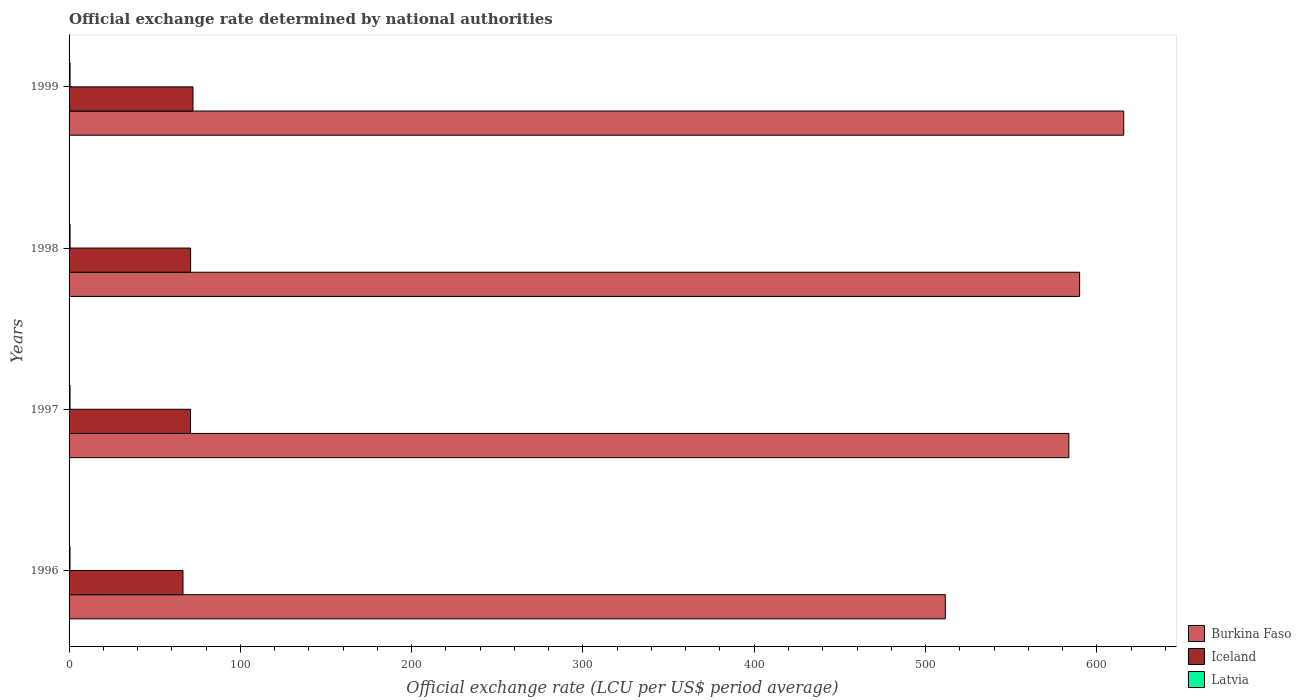How many different coloured bars are there?
Provide a short and direct response. 3. Are the number of bars per tick equal to the number of legend labels?
Keep it short and to the point. Yes. Are the number of bars on each tick of the Y-axis equal?
Make the answer very short. Yes. In how many cases, is the number of bars for a given year not equal to the number of legend labels?
Provide a short and direct response. 0. What is the official exchange rate in Burkina Faso in 1997?
Offer a very short reply. 583.67. Across all years, what is the maximum official exchange rate in Latvia?
Provide a short and direct response. 0.59. Across all years, what is the minimum official exchange rate in Iceland?
Provide a succinct answer. 66.5. What is the total official exchange rate in Latvia in the graph?
Provide a succinct answer. 2.31. What is the difference between the official exchange rate in Burkina Faso in 1997 and that in 1999?
Offer a very short reply. -32.03. What is the difference between the official exchange rate in Latvia in 1998 and the official exchange rate in Iceland in 1999?
Your answer should be compact. -71.75. What is the average official exchange rate in Burkina Faso per year?
Your response must be concise. 575.22. In the year 1998, what is the difference between the official exchange rate in Latvia and official exchange rate in Burkina Faso?
Offer a very short reply. -589.36. What is the ratio of the official exchange rate in Burkina Faso in 1997 to that in 1999?
Your answer should be very brief. 0.95. What is the difference between the highest and the second highest official exchange rate in Burkina Faso?
Your answer should be compact. 25.75. What is the difference between the highest and the lowest official exchange rate in Burkina Faso?
Your response must be concise. 104.15. Is the sum of the official exchange rate in Burkina Faso in 1996 and 1998 greater than the maximum official exchange rate in Iceland across all years?
Give a very brief answer. Yes. What does the 1st bar from the top in 1998 represents?
Make the answer very short. Latvia. What does the 1st bar from the bottom in 1998 represents?
Offer a terse response. Burkina Faso. Are the values on the major ticks of X-axis written in scientific E-notation?
Provide a short and direct response. No. Where does the legend appear in the graph?
Your response must be concise. Bottom right. How many legend labels are there?
Your response must be concise. 3. How are the legend labels stacked?
Offer a very short reply. Vertical. What is the title of the graph?
Give a very brief answer. Official exchange rate determined by national authorities. Does "Turkey" appear as one of the legend labels in the graph?
Ensure brevity in your answer.  No. What is the label or title of the X-axis?
Keep it short and to the point. Official exchange rate (LCU per US$ period average). What is the Official exchange rate (LCU per US$ period average) in Burkina Faso in 1996?
Offer a very short reply. 511.55. What is the Official exchange rate (LCU per US$ period average) in Iceland in 1996?
Offer a terse response. 66.5. What is the Official exchange rate (LCU per US$ period average) of Latvia in 1996?
Your answer should be compact. 0.55. What is the Official exchange rate (LCU per US$ period average) in Burkina Faso in 1997?
Your answer should be very brief. 583.67. What is the Official exchange rate (LCU per US$ period average) in Iceland in 1997?
Give a very brief answer. 70.9. What is the Official exchange rate (LCU per US$ period average) of Latvia in 1997?
Your answer should be compact. 0.58. What is the Official exchange rate (LCU per US$ period average) of Burkina Faso in 1998?
Your response must be concise. 589.95. What is the Official exchange rate (LCU per US$ period average) in Iceland in 1998?
Your answer should be compact. 70.96. What is the Official exchange rate (LCU per US$ period average) of Latvia in 1998?
Offer a very short reply. 0.59. What is the Official exchange rate (LCU per US$ period average) in Burkina Faso in 1999?
Offer a terse response. 615.7. What is the Official exchange rate (LCU per US$ period average) in Iceland in 1999?
Give a very brief answer. 72.34. What is the Official exchange rate (LCU per US$ period average) in Latvia in 1999?
Provide a short and direct response. 0.59. Across all years, what is the maximum Official exchange rate (LCU per US$ period average) in Burkina Faso?
Keep it short and to the point. 615.7. Across all years, what is the maximum Official exchange rate (LCU per US$ period average) of Iceland?
Provide a succinct answer. 72.34. Across all years, what is the maximum Official exchange rate (LCU per US$ period average) in Latvia?
Provide a succinct answer. 0.59. Across all years, what is the minimum Official exchange rate (LCU per US$ period average) of Burkina Faso?
Make the answer very short. 511.55. Across all years, what is the minimum Official exchange rate (LCU per US$ period average) of Iceland?
Make the answer very short. 66.5. Across all years, what is the minimum Official exchange rate (LCU per US$ period average) in Latvia?
Make the answer very short. 0.55. What is the total Official exchange rate (LCU per US$ period average) of Burkina Faso in the graph?
Offer a very short reply. 2300.87. What is the total Official exchange rate (LCU per US$ period average) of Iceland in the graph?
Ensure brevity in your answer.  280.7. What is the total Official exchange rate (LCU per US$ period average) in Latvia in the graph?
Provide a succinct answer. 2.31. What is the difference between the Official exchange rate (LCU per US$ period average) of Burkina Faso in 1996 and that in 1997?
Keep it short and to the point. -72.12. What is the difference between the Official exchange rate (LCU per US$ period average) of Iceland in 1996 and that in 1997?
Ensure brevity in your answer.  -4.4. What is the difference between the Official exchange rate (LCU per US$ period average) in Latvia in 1996 and that in 1997?
Give a very brief answer. -0.03. What is the difference between the Official exchange rate (LCU per US$ period average) of Burkina Faso in 1996 and that in 1998?
Give a very brief answer. -78.4. What is the difference between the Official exchange rate (LCU per US$ period average) of Iceland in 1996 and that in 1998?
Offer a very short reply. -4.46. What is the difference between the Official exchange rate (LCU per US$ period average) of Latvia in 1996 and that in 1998?
Ensure brevity in your answer.  -0.04. What is the difference between the Official exchange rate (LCU per US$ period average) in Burkina Faso in 1996 and that in 1999?
Your answer should be very brief. -104.15. What is the difference between the Official exchange rate (LCU per US$ period average) in Iceland in 1996 and that in 1999?
Offer a terse response. -5.84. What is the difference between the Official exchange rate (LCU per US$ period average) of Latvia in 1996 and that in 1999?
Offer a very short reply. -0.03. What is the difference between the Official exchange rate (LCU per US$ period average) of Burkina Faso in 1997 and that in 1998?
Your answer should be very brief. -6.28. What is the difference between the Official exchange rate (LCU per US$ period average) in Iceland in 1997 and that in 1998?
Keep it short and to the point. -0.05. What is the difference between the Official exchange rate (LCU per US$ period average) in Latvia in 1997 and that in 1998?
Provide a short and direct response. -0.01. What is the difference between the Official exchange rate (LCU per US$ period average) of Burkina Faso in 1997 and that in 1999?
Keep it short and to the point. -32.03. What is the difference between the Official exchange rate (LCU per US$ period average) of Iceland in 1997 and that in 1999?
Make the answer very short. -1.43. What is the difference between the Official exchange rate (LCU per US$ period average) of Latvia in 1997 and that in 1999?
Your answer should be very brief. -0. What is the difference between the Official exchange rate (LCU per US$ period average) in Burkina Faso in 1998 and that in 1999?
Make the answer very short. -25.75. What is the difference between the Official exchange rate (LCU per US$ period average) of Iceland in 1998 and that in 1999?
Make the answer very short. -1.38. What is the difference between the Official exchange rate (LCU per US$ period average) of Latvia in 1998 and that in 1999?
Provide a short and direct response. 0. What is the difference between the Official exchange rate (LCU per US$ period average) in Burkina Faso in 1996 and the Official exchange rate (LCU per US$ period average) in Iceland in 1997?
Offer a terse response. 440.65. What is the difference between the Official exchange rate (LCU per US$ period average) in Burkina Faso in 1996 and the Official exchange rate (LCU per US$ period average) in Latvia in 1997?
Your answer should be compact. 510.97. What is the difference between the Official exchange rate (LCU per US$ period average) of Iceland in 1996 and the Official exchange rate (LCU per US$ period average) of Latvia in 1997?
Provide a short and direct response. 65.92. What is the difference between the Official exchange rate (LCU per US$ period average) of Burkina Faso in 1996 and the Official exchange rate (LCU per US$ period average) of Iceland in 1998?
Keep it short and to the point. 440.59. What is the difference between the Official exchange rate (LCU per US$ period average) of Burkina Faso in 1996 and the Official exchange rate (LCU per US$ period average) of Latvia in 1998?
Provide a succinct answer. 510.96. What is the difference between the Official exchange rate (LCU per US$ period average) of Iceland in 1996 and the Official exchange rate (LCU per US$ period average) of Latvia in 1998?
Ensure brevity in your answer.  65.91. What is the difference between the Official exchange rate (LCU per US$ period average) of Burkina Faso in 1996 and the Official exchange rate (LCU per US$ period average) of Iceland in 1999?
Keep it short and to the point. 439.22. What is the difference between the Official exchange rate (LCU per US$ period average) of Burkina Faso in 1996 and the Official exchange rate (LCU per US$ period average) of Latvia in 1999?
Your response must be concise. 510.97. What is the difference between the Official exchange rate (LCU per US$ period average) in Iceland in 1996 and the Official exchange rate (LCU per US$ period average) in Latvia in 1999?
Provide a short and direct response. 65.91. What is the difference between the Official exchange rate (LCU per US$ period average) in Burkina Faso in 1997 and the Official exchange rate (LCU per US$ period average) in Iceland in 1998?
Your response must be concise. 512.71. What is the difference between the Official exchange rate (LCU per US$ period average) in Burkina Faso in 1997 and the Official exchange rate (LCU per US$ period average) in Latvia in 1998?
Give a very brief answer. 583.08. What is the difference between the Official exchange rate (LCU per US$ period average) in Iceland in 1997 and the Official exchange rate (LCU per US$ period average) in Latvia in 1998?
Your answer should be compact. 70.31. What is the difference between the Official exchange rate (LCU per US$ period average) of Burkina Faso in 1997 and the Official exchange rate (LCU per US$ period average) of Iceland in 1999?
Your answer should be very brief. 511.33. What is the difference between the Official exchange rate (LCU per US$ period average) of Burkina Faso in 1997 and the Official exchange rate (LCU per US$ period average) of Latvia in 1999?
Offer a very short reply. 583.08. What is the difference between the Official exchange rate (LCU per US$ period average) in Iceland in 1997 and the Official exchange rate (LCU per US$ period average) in Latvia in 1999?
Ensure brevity in your answer.  70.32. What is the difference between the Official exchange rate (LCU per US$ period average) of Burkina Faso in 1998 and the Official exchange rate (LCU per US$ period average) of Iceland in 1999?
Your answer should be compact. 517.62. What is the difference between the Official exchange rate (LCU per US$ period average) in Burkina Faso in 1998 and the Official exchange rate (LCU per US$ period average) in Latvia in 1999?
Your answer should be compact. 589.37. What is the difference between the Official exchange rate (LCU per US$ period average) in Iceland in 1998 and the Official exchange rate (LCU per US$ period average) in Latvia in 1999?
Provide a succinct answer. 70.37. What is the average Official exchange rate (LCU per US$ period average) in Burkina Faso per year?
Your response must be concise. 575.22. What is the average Official exchange rate (LCU per US$ period average) of Iceland per year?
Make the answer very short. 70.17. What is the average Official exchange rate (LCU per US$ period average) of Latvia per year?
Your answer should be compact. 0.58. In the year 1996, what is the difference between the Official exchange rate (LCU per US$ period average) of Burkina Faso and Official exchange rate (LCU per US$ period average) of Iceland?
Provide a succinct answer. 445.05. In the year 1996, what is the difference between the Official exchange rate (LCU per US$ period average) in Burkina Faso and Official exchange rate (LCU per US$ period average) in Latvia?
Give a very brief answer. 511. In the year 1996, what is the difference between the Official exchange rate (LCU per US$ period average) in Iceland and Official exchange rate (LCU per US$ period average) in Latvia?
Your response must be concise. 65.95. In the year 1997, what is the difference between the Official exchange rate (LCU per US$ period average) of Burkina Faso and Official exchange rate (LCU per US$ period average) of Iceland?
Your response must be concise. 512.77. In the year 1997, what is the difference between the Official exchange rate (LCU per US$ period average) of Burkina Faso and Official exchange rate (LCU per US$ period average) of Latvia?
Give a very brief answer. 583.09. In the year 1997, what is the difference between the Official exchange rate (LCU per US$ period average) of Iceland and Official exchange rate (LCU per US$ period average) of Latvia?
Offer a very short reply. 70.32. In the year 1998, what is the difference between the Official exchange rate (LCU per US$ period average) of Burkina Faso and Official exchange rate (LCU per US$ period average) of Iceland?
Provide a succinct answer. 518.99. In the year 1998, what is the difference between the Official exchange rate (LCU per US$ period average) in Burkina Faso and Official exchange rate (LCU per US$ period average) in Latvia?
Provide a succinct answer. 589.36. In the year 1998, what is the difference between the Official exchange rate (LCU per US$ period average) in Iceland and Official exchange rate (LCU per US$ period average) in Latvia?
Your answer should be very brief. 70.37. In the year 1999, what is the difference between the Official exchange rate (LCU per US$ period average) of Burkina Faso and Official exchange rate (LCU per US$ period average) of Iceland?
Offer a very short reply. 543.36. In the year 1999, what is the difference between the Official exchange rate (LCU per US$ period average) of Burkina Faso and Official exchange rate (LCU per US$ period average) of Latvia?
Provide a short and direct response. 615.11. In the year 1999, what is the difference between the Official exchange rate (LCU per US$ period average) in Iceland and Official exchange rate (LCU per US$ period average) in Latvia?
Your answer should be very brief. 71.75. What is the ratio of the Official exchange rate (LCU per US$ period average) in Burkina Faso in 1996 to that in 1997?
Give a very brief answer. 0.88. What is the ratio of the Official exchange rate (LCU per US$ period average) of Iceland in 1996 to that in 1997?
Your answer should be very brief. 0.94. What is the ratio of the Official exchange rate (LCU per US$ period average) in Latvia in 1996 to that in 1997?
Ensure brevity in your answer.  0.95. What is the ratio of the Official exchange rate (LCU per US$ period average) in Burkina Faso in 1996 to that in 1998?
Ensure brevity in your answer.  0.87. What is the ratio of the Official exchange rate (LCU per US$ period average) of Iceland in 1996 to that in 1998?
Your response must be concise. 0.94. What is the ratio of the Official exchange rate (LCU per US$ period average) in Latvia in 1996 to that in 1998?
Offer a terse response. 0.93. What is the ratio of the Official exchange rate (LCU per US$ period average) in Burkina Faso in 1996 to that in 1999?
Offer a very short reply. 0.83. What is the ratio of the Official exchange rate (LCU per US$ period average) of Iceland in 1996 to that in 1999?
Give a very brief answer. 0.92. What is the ratio of the Official exchange rate (LCU per US$ period average) of Iceland in 1997 to that in 1998?
Provide a succinct answer. 1. What is the ratio of the Official exchange rate (LCU per US$ period average) of Latvia in 1997 to that in 1998?
Give a very brief answer. 0.98. What is the ratio of the Official exchange rate (LCU per US$ period average) of Burkina Faso in 1997 to that in 1999?
Offer a terse response. 0.95. What is the ratio of the Official exchange rate (LCU per US$ period average) in Iceland in 1997 to that in 1999?
Ensure brevity in your answer.  0.98. What is the ratio of the Official exchange rate (LCU per US$ period average) of Burkina Faso in 1998 to that in 1999?
Keep it short and to the point. 0.96. What is the difference between the highest and the second highest Official exchange rate (LCU per US$ period average) in Burkina Faso?
Your answer should be compact. 25.75. What is the difference between the highest and the second highest Official exchange rate (LCU per US$ period average) in Iceland?
Provide a succinct answer. 1.38. What is the difference between the highest and the second highest Official exchange rate (LCU per US$ period average) in Latvia?
Provide a short and direct response. 0. What is the difference between the highest and the lowest Official exchange rate (LCU per US$ period average) of Burkina Faso?
Offer a very short reply. 104.15. What is the difference between the highest and the lowest Official exchange rate (LCU per US$ period average) in Iceland?
Make the answer very short. 5.84. What is the difference between the highest and the lowest Official exchange rate (LCU per US$ period average) in Latvia?
Provide a succinct answer. 0.04. 